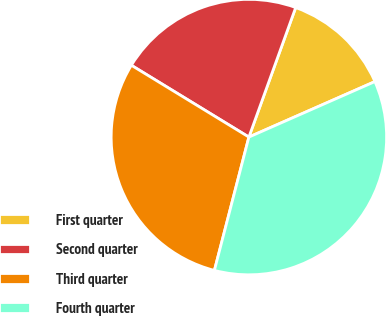<chart> <loc_0><loc_0><loc_500><loc_500><pie_chart><fcel>First quarter<fcel>Second quarter<fcel>Third quarter<fcel>Fourth quarter<nl><fcel>12.88%<fcel>21.79%<fcel>29.7%<fcel>35.63%<nl></chart> 